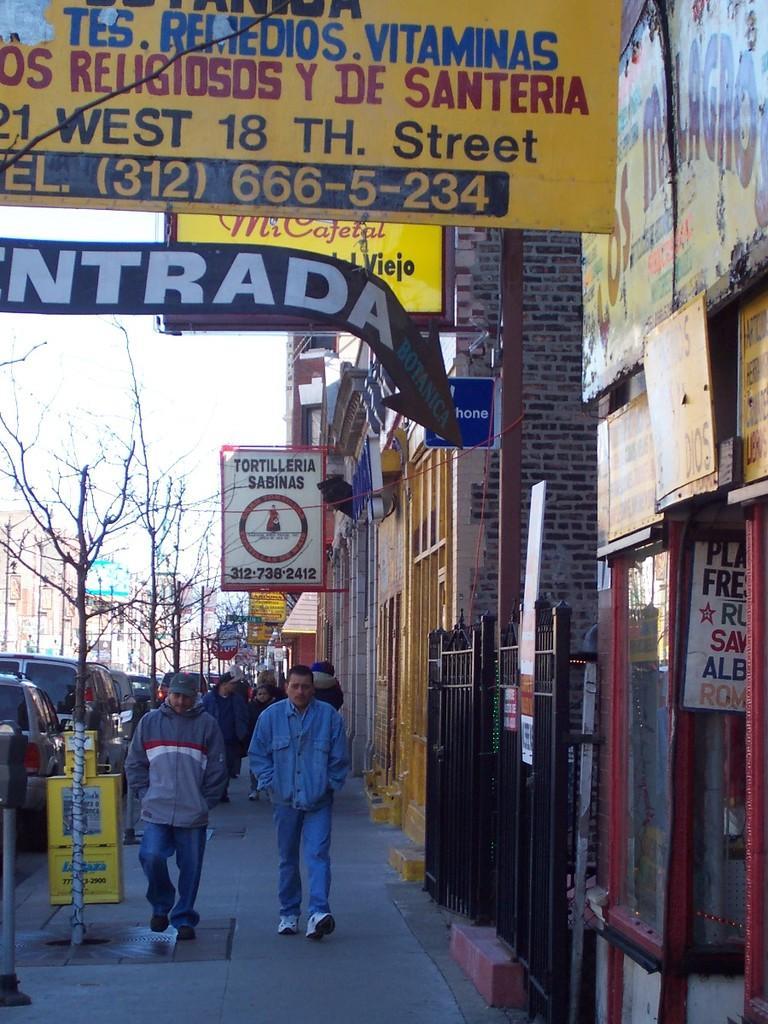Describe this image in one or two sentences. In the image in the center we can see trees,buildings,sign boards,banners,glass,gate,brick wall,pole,few vehicles and few people were walking. In the background we can see the sky and clouds. 